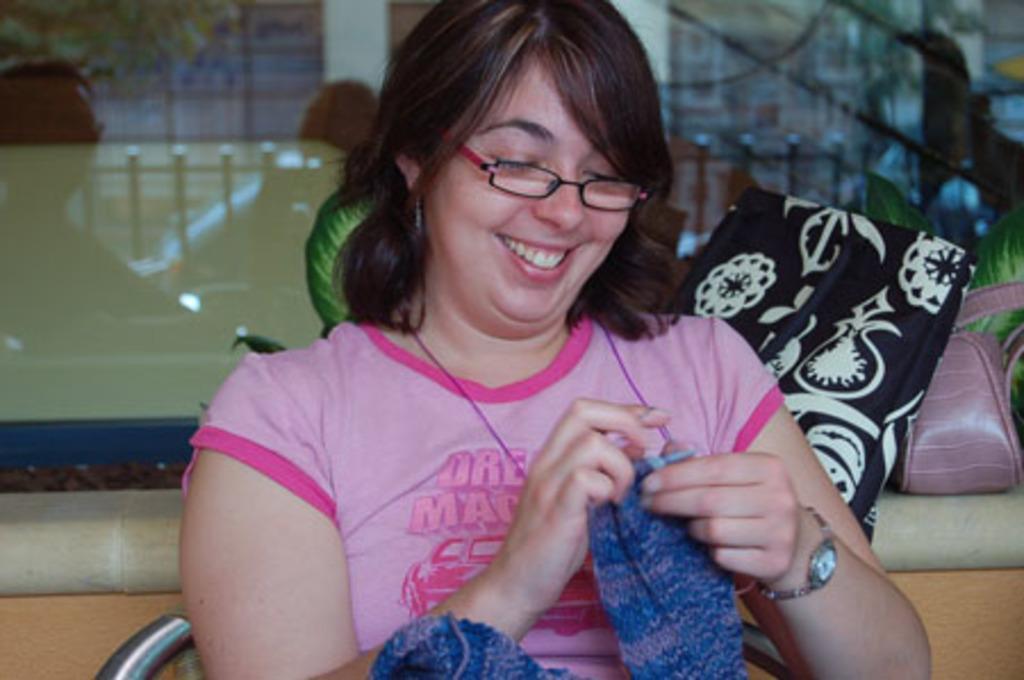How would you summarize this image in a sentence or two? In this picture there is a woman sitting on a chair and smiling and holding a cloth, behind her we can see bags on the platform, leaves and glass. 